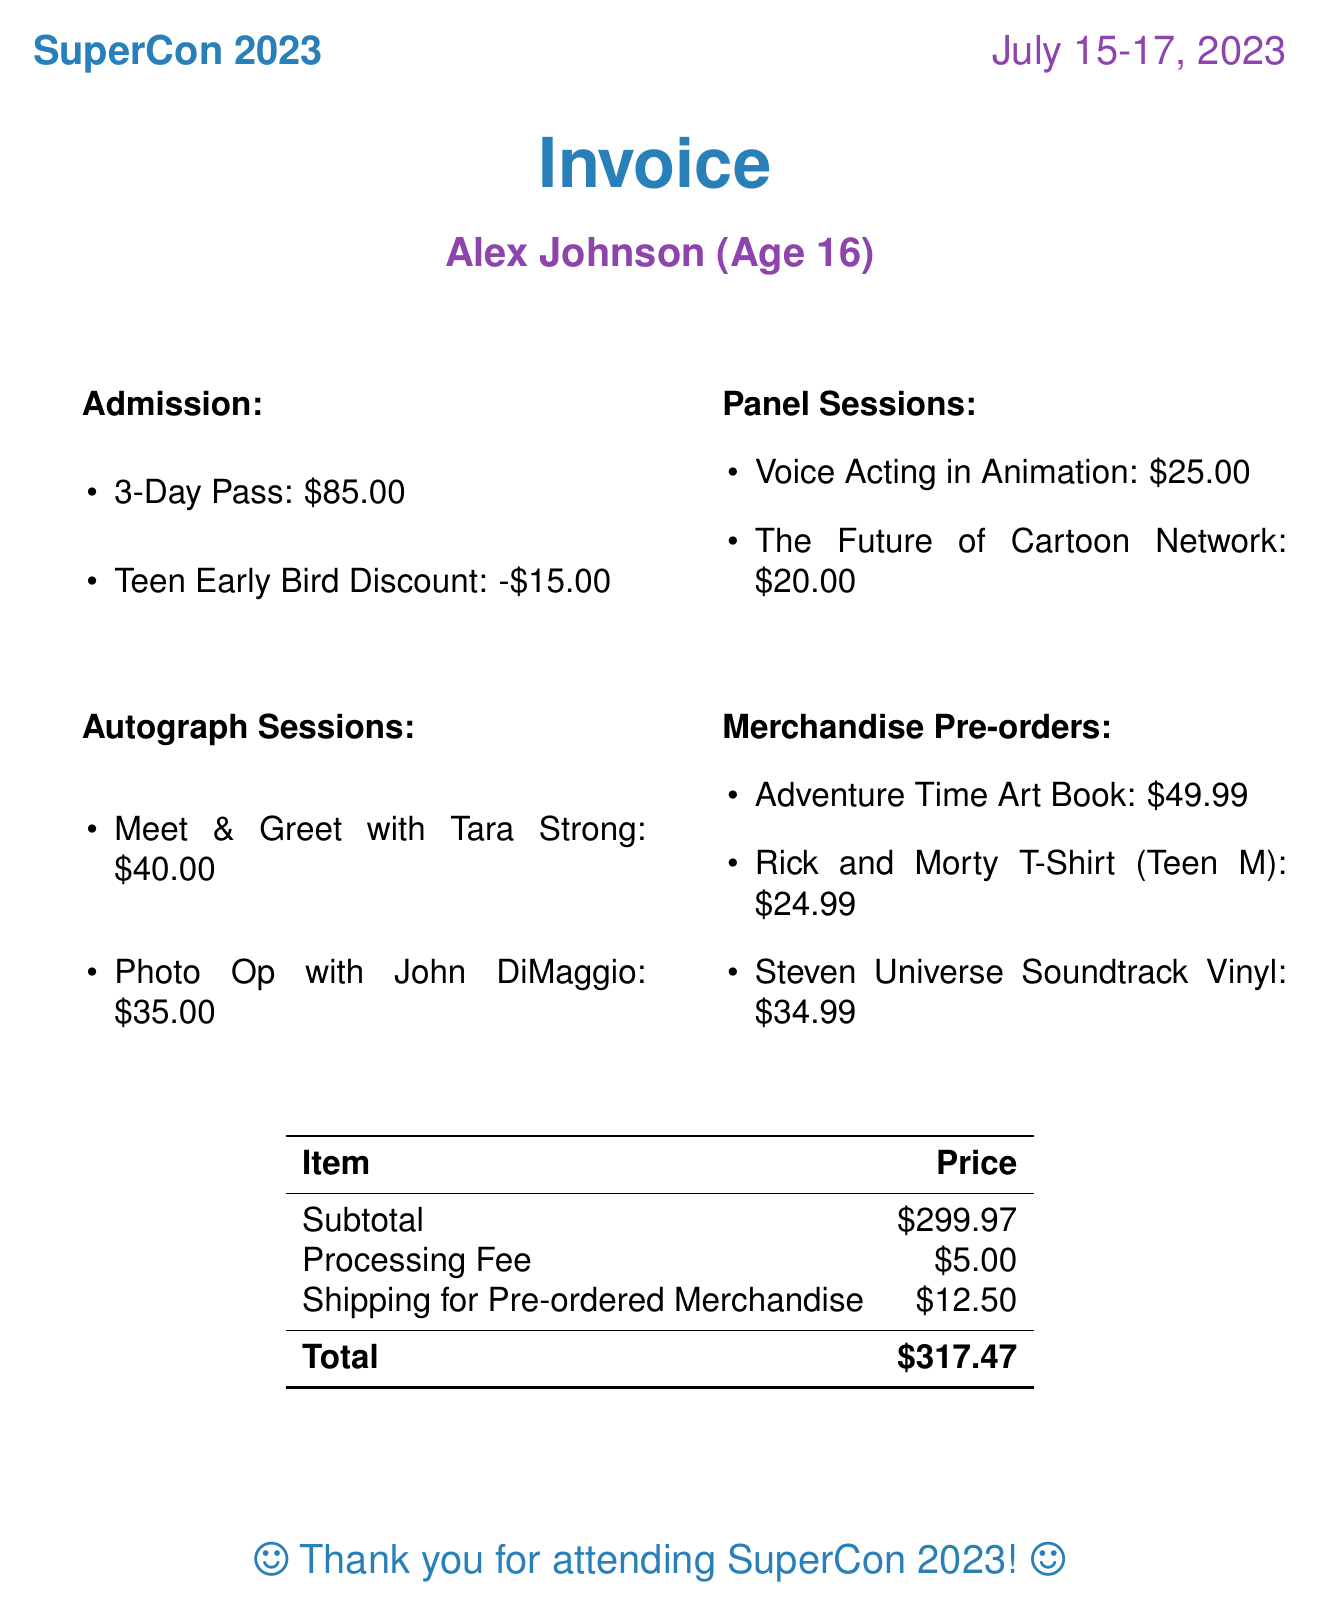What is the event name? The event is titled "SuperCon 2023."
Answer: SuperCon 2023 Who is the attendee? The invoice lists "Alex Johnson" as the attendee's name.
Answer: Alex Johnson What is the price of the 3-Day Pass? The cost for the 3-Day Pass is shown in the admission items of the document.
Answer: 85.00 How much is the discount for the Teen Early Bird? The document specifies the discount amount provided to teenagers for early bird admission.
Answer: -15.00 Who is the speaker for the "Voice Acting in Animation" panel? The invoice provides the speaker's name alongside the panel session details.
Answer: Tom Kenny (SpongeBob SquarePants) What is the total cost of the invoice? The total is presented clearly in the summary of the document after adding all costs and fees.
Answer: 317.47 How many autograph sessions are listed? The document provides a count of the autograph sessions included in the invoice.
Answer: 2 What is the shipping cost for pre-ordered merchandise? The invoice includes a specific fee for shipping related to pre-ordered items.
Answer: 12.50 What is one merchandise item listed? The merchandise section contains multiple items; one example is requested.
Answer: Limited Edition Adventure Time Art Book What age is the attendee? The age of the attendee is mentioned in the introductory details of the invoice.
Answer: 16 